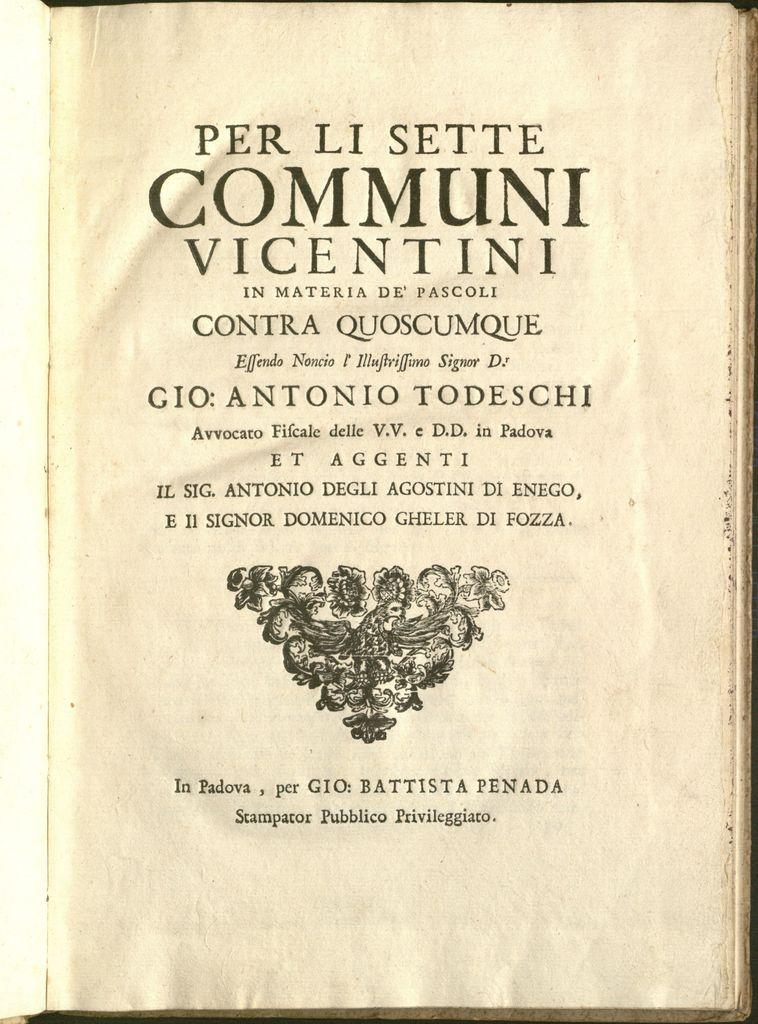<image>
Provide a brief description of the given image. The Communi Vicentini is set on a table for display. 